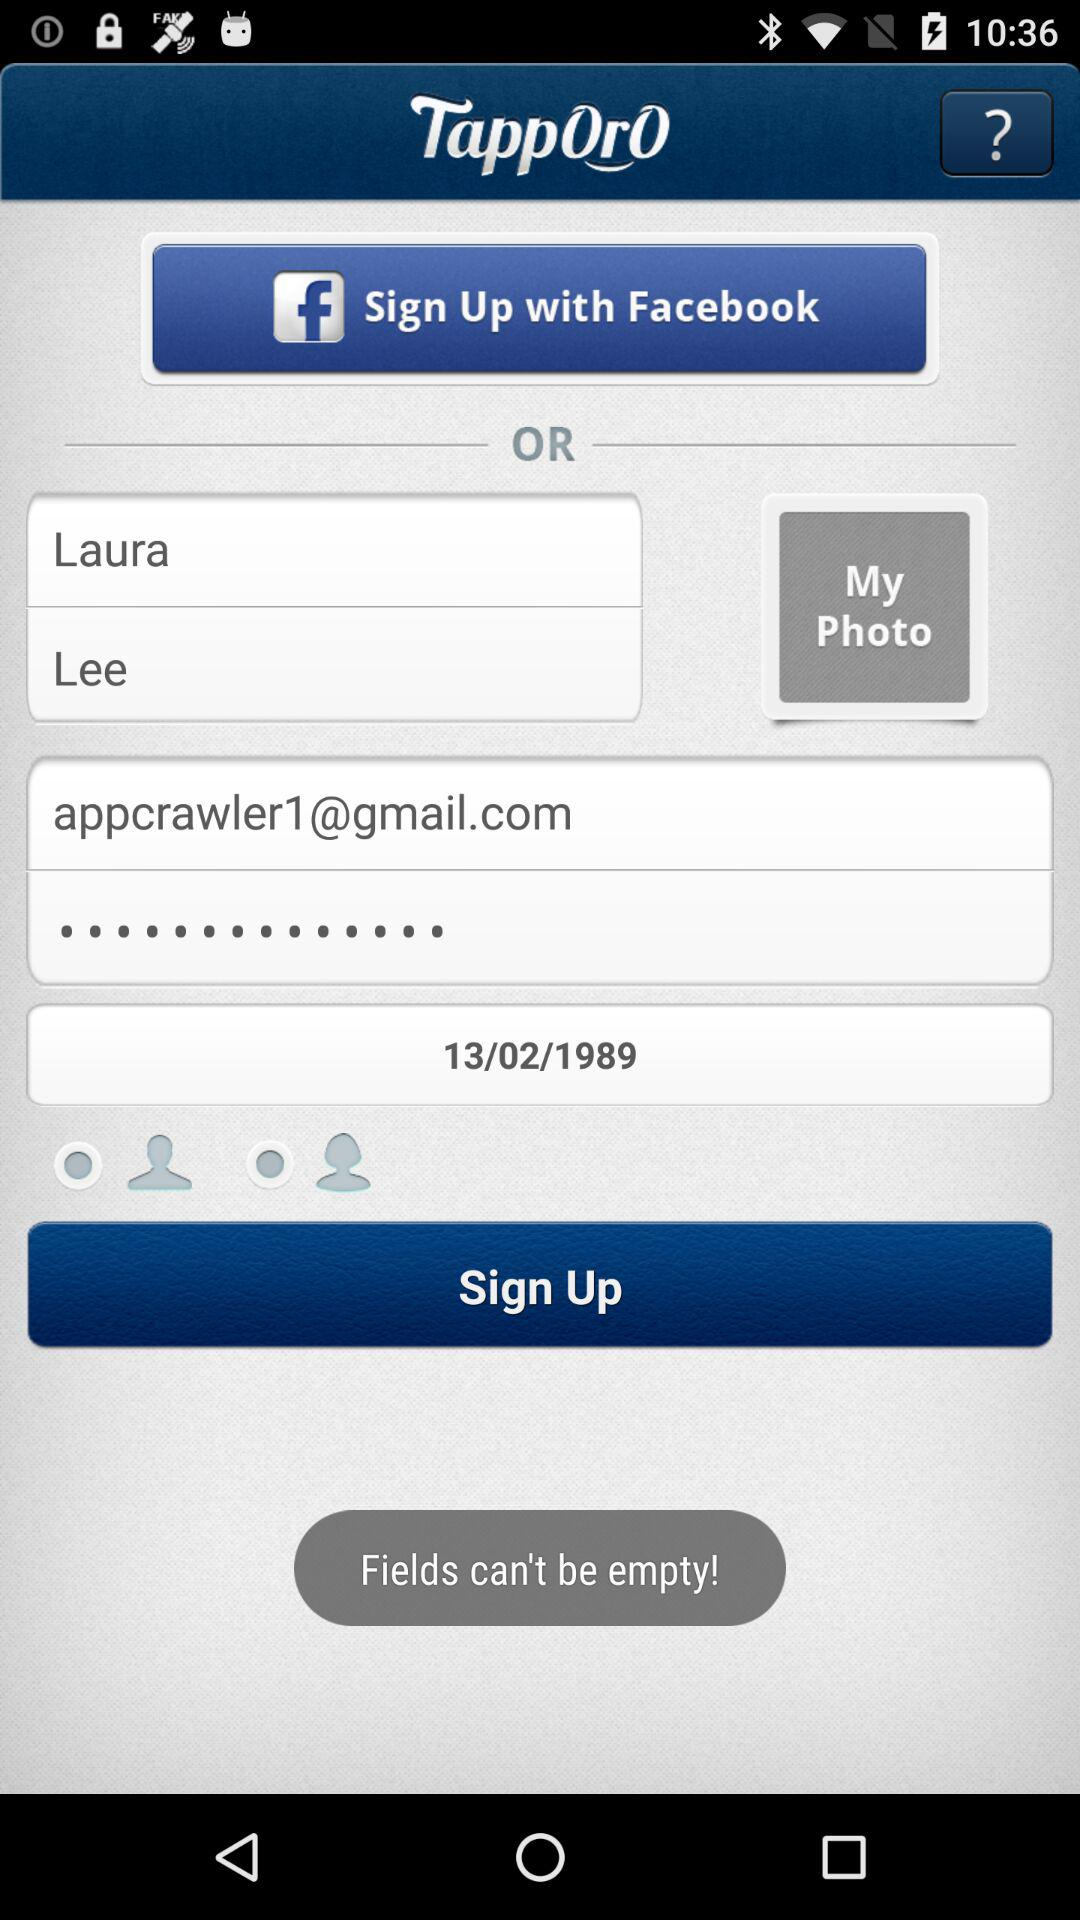What is the application name? The application name is "TappOrO". 